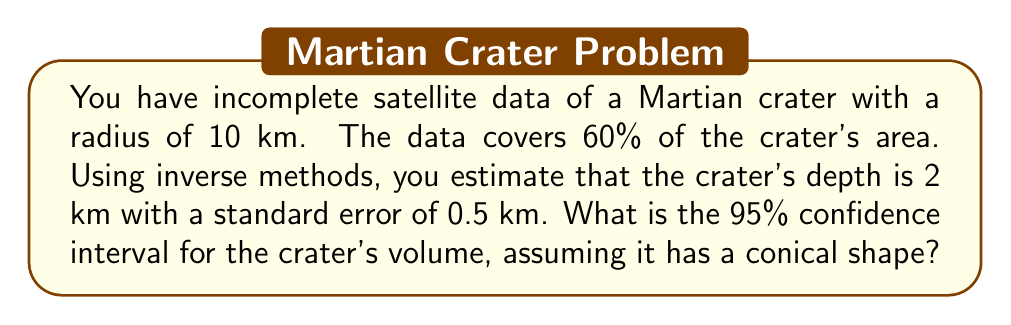Teach me how to tackle this problem. Let's approach this step-by-step:

1) The volume of a cone is given by the formula:
   $$V = \frac{1}{3}\pi r^2 h$$
   where $r$ is the radius and $h$ is the height (depth in this case).

2) We know:
   $r = 10$ km
   $h = 2$ km (estimated)
   Standard error of $h = 0.5$ km

3) First, let's calculate the point estimate for the volume:
   $$V = \frac{1}{3}\pi (10^2)(2) = \frac{200\pi}{3} \approx 209.44 \text{ km}^3$$

4) For a 95% confidence interval, we use 1.96 standard errors on either side of the point estimate.

5) The standard error of the volume can be calculated using the delta method:
   $$SE(V) = \left|\frac{\partial V}{\partial h}\right| \cdot SE(h) = \left|\frac{1}{3}\pi r^2\right| \cdot SE(h) = \frac{100\pi}{3} \cdot 0.5 \approx 52.36 \text{ km}^3$$

6) The 95% confidence interval is:
   $$\text{CI} = \text{Point Estimate} \pm 1.96 \cdot SE$$
   Lower bound: $209.44 - 1.96(52.36) \approx 106.85 \text{ km}^3$
   Upper bound: $209.44 + 1.96(52.36) \approx 312.03 \text{ km}^3$

Therefore, the 95% confidence interval for the crater's volume is approximately (106.85 km³, 312.03 km³).
Answer: (106.85 km³, 312.03 km³) 